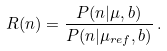<formula> <loc_0><loc_0><loc_500><loc_500>R ( n ) = \frac { P ( n | \mu , b ) } { P ( n | \mu _ { r e f } , b ) } \, .</formula> 